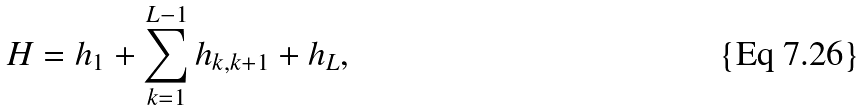Convert formula to latex. <formula><loc_0><loc_0><loc_500><loc_500>H = h _ { 1 } + \sum _ { k = 1 } ^ { L - 1 } h _ { k , k + 1 } + h _ { L } ,</formula> 